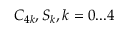<formula> <loc_0><loc_0><loc_500><loc_500>C _ { 4 k } , S _ { k } , k = 0 \dots 4</formula> 